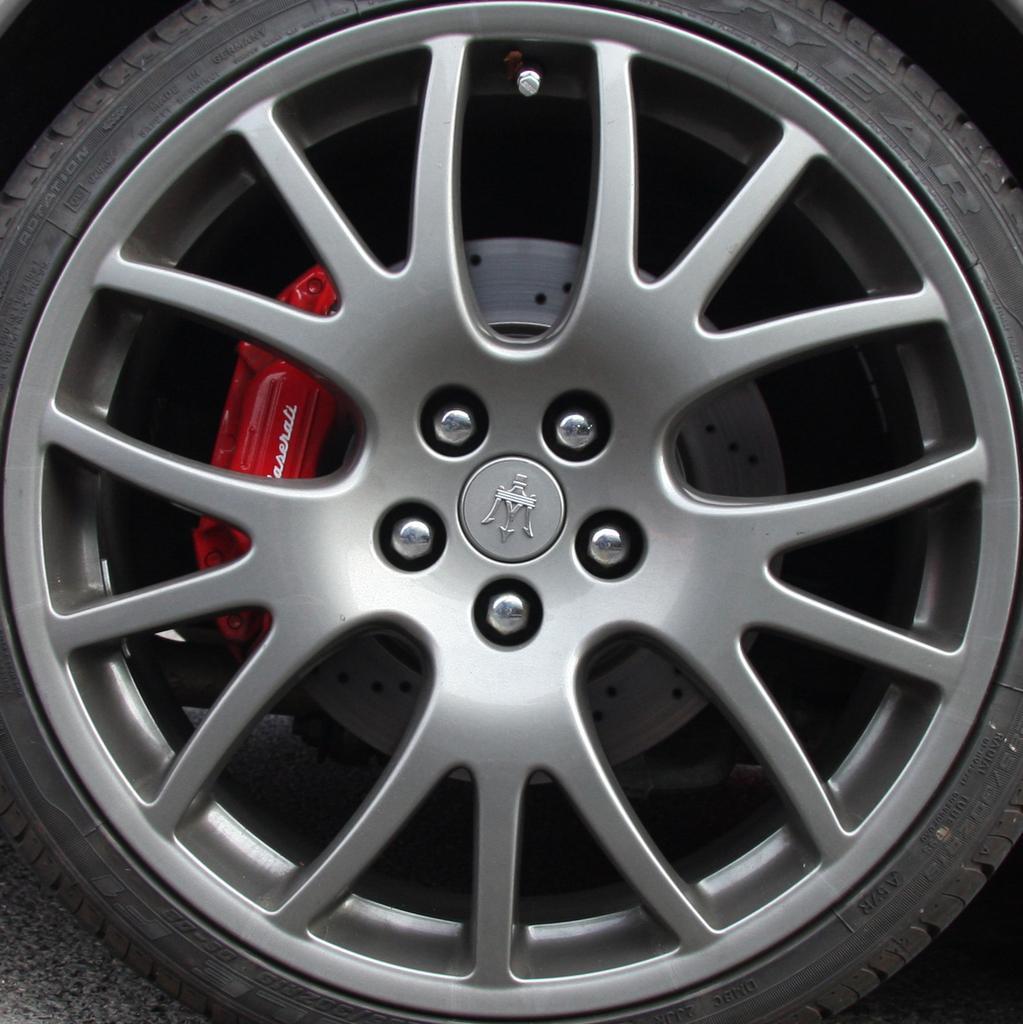Could you give a brief overview of what you see in this image? In this picture we can see a wheel of a vehicle on the ground, here we can see a brake pad. 